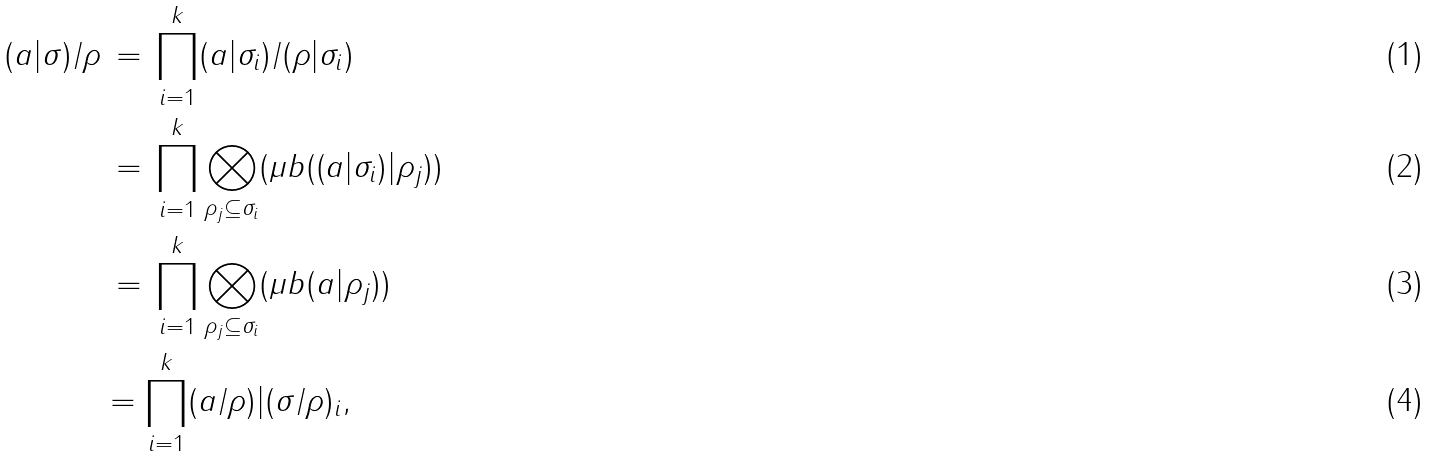<formula> <loc_0><loc_0><loc_500><loc_500>( a | \sigma ) / \rho & \, = \, \prod _ { i = 1 } ^ { k } ( a | \sigma _ { i } ) / ( \rho | \sigma _ { i } ) \\ & \, = \, \prod _ { i = 1 } ^ { k } \bigotimes _ { \rho _ { j } \subseteq \sigma _ { i } } ( \mu b ( ( a | \sigma _ { i } ) | \rho _ { j } ) ) \\ & \, = \, \prod _ { i = 1 } ^ { k } \bigotimes _ { \rho _ { j } \subseteq \sigma _ { i } } ( \mu b ( a | \rho _ { j } ) ) \\ & = \prod _ { i = 1 } ^ { k } ( a / \rho ) | ( \sigma / \rho ) _ { i } ,</formula> 